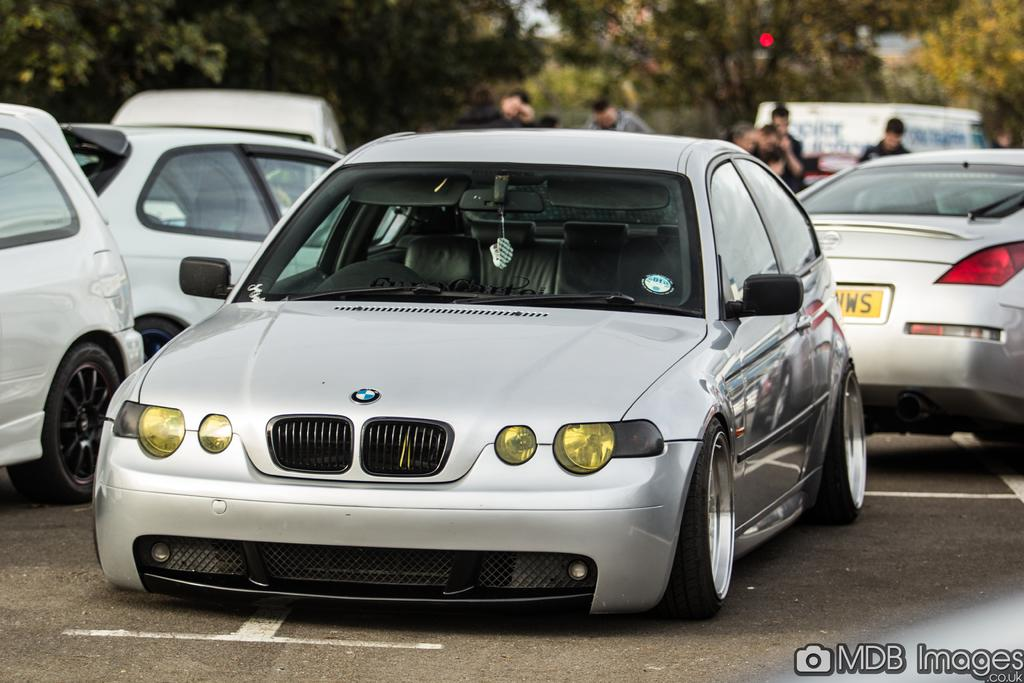What type of vehicles can be seen on the road in the image? There are cars on the road in the image. Are there any people present on the road in the image? Yes, there are persons on the road in the image. What can be seen in the distance in the image? Trees are visible in the background of the image. Is there a boy wearing a veil in the image? There is no boy wearing a veil in the image. What type of sponge is being used to clean the cars in the image? There is no sponge visible in the image, and the cars are not being cleaned. 